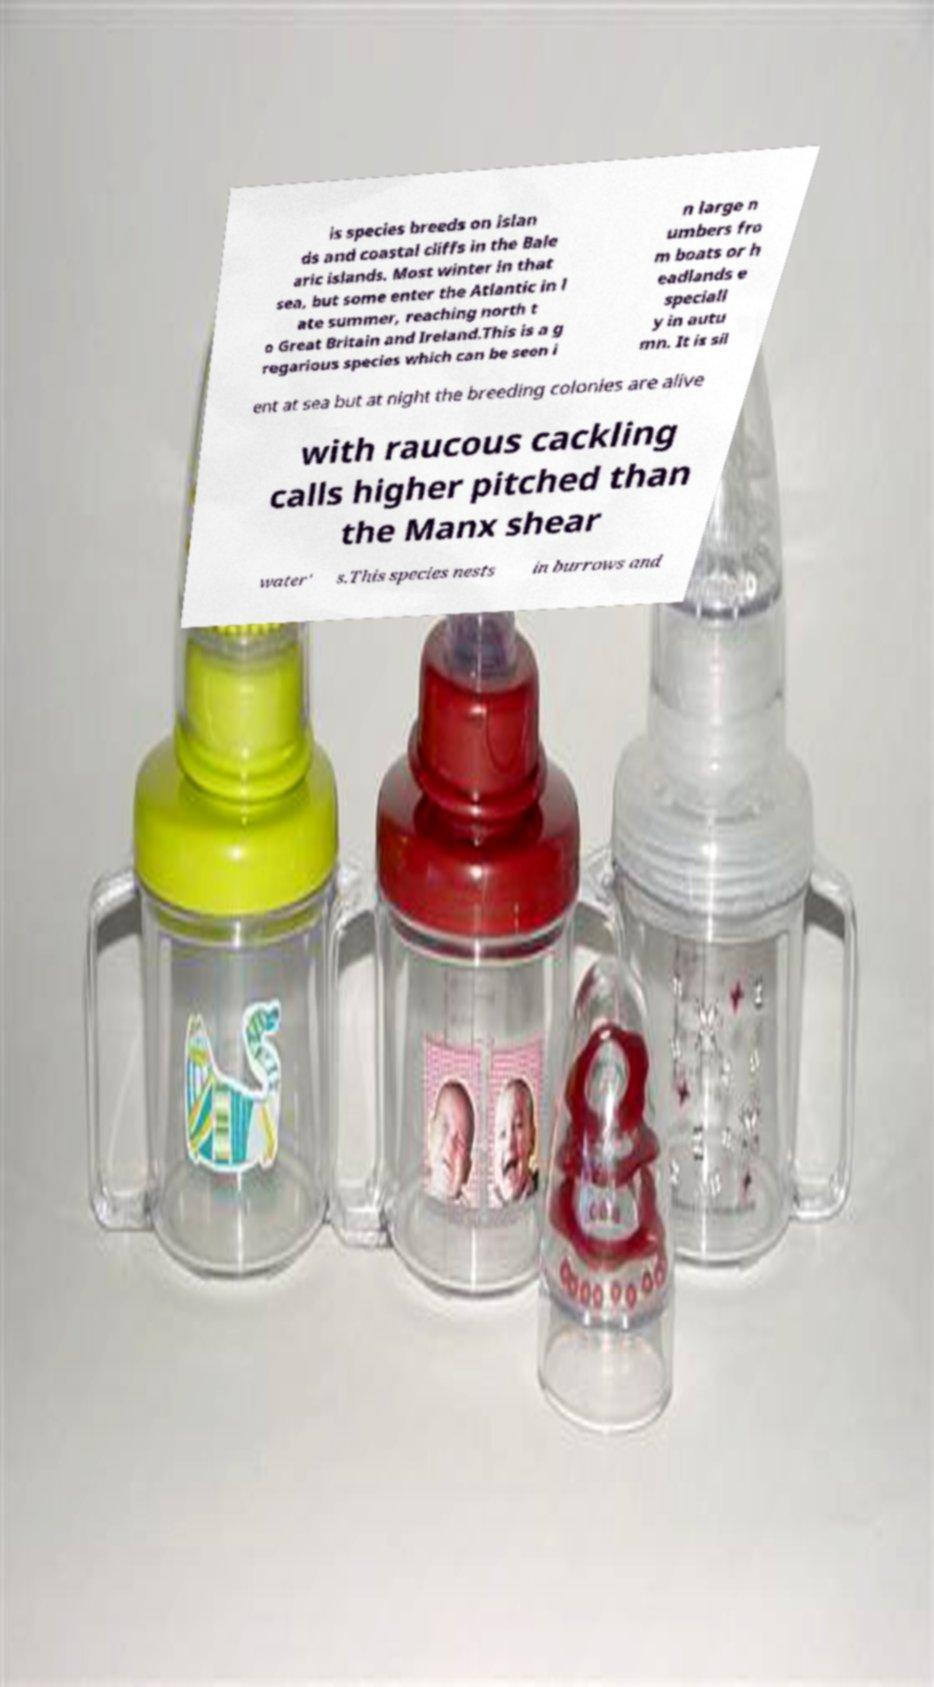Can you accurately transcribe the text from the provided image for me? is species breeds on islan ds and coastal cliffs in the Bale aric islands. Most winter in that sea, but some enter the Atlantic in l ate summer, reaching north t o Great Britain and Ireland.This is a g regarious species which can be seen i n large n umbers fro m boats or h eadlands e speciall y in autu mn. It is sil ent at sea but at night the breeding colonies are alive with raucous cackling calls higher pitched than the Manx shear water' s.This species nests in burrows and 